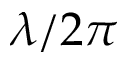<formula> <loc_0><loc_0><loc_500><loc_500>\lambda / 2 \pi</formula> 